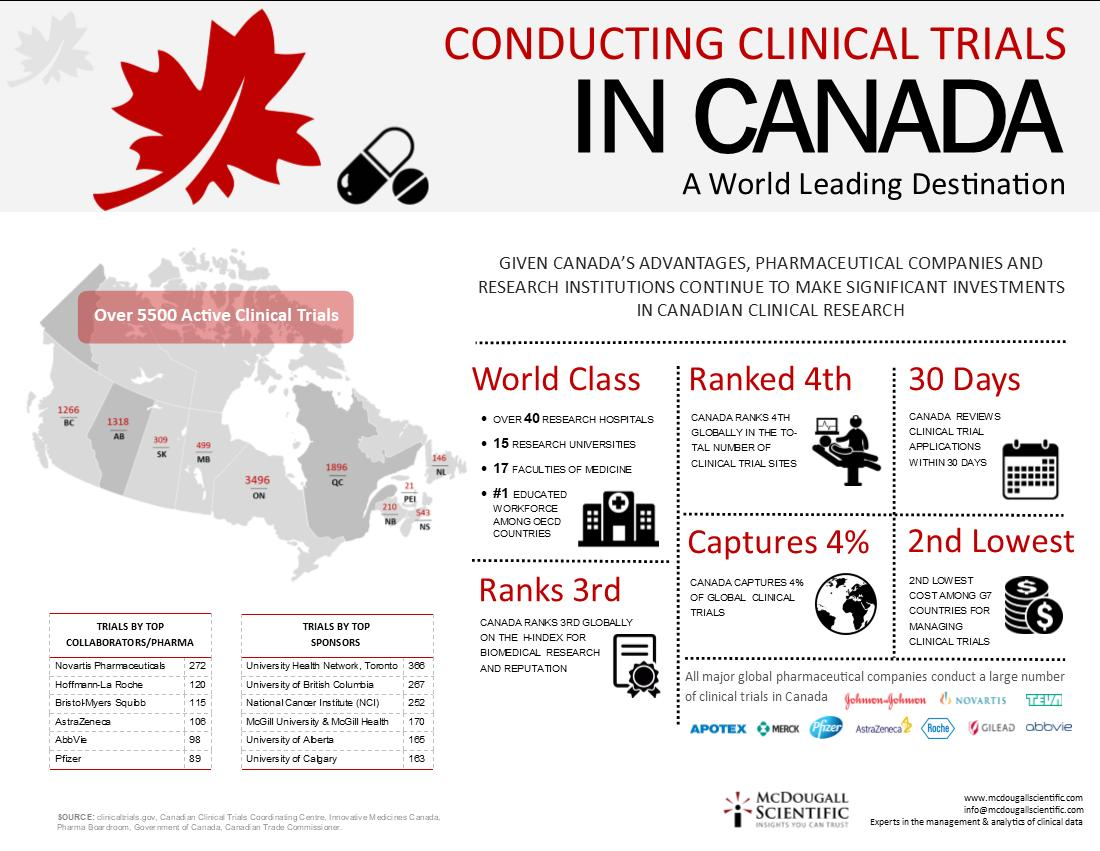Outline some significant characteristics in this image. According to the data provided, Prince Edward Island has the least number of active clinical trials among the four Canadian provinces of Manitoba, Ontario, and Quebec. There are 1896 active clinical trials taking place in Quebec. The University of British Columbia conducted 267 clinical trials. There are currently 499 active clinical trials taking place in the province of Manitoba. According to the information provided, Ontario is the Canadian province with the highest number of active clinical trials. 